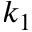<formula> <loc_0><loc_0><loc_500><loc_500>k _ { 1 }</formula> 